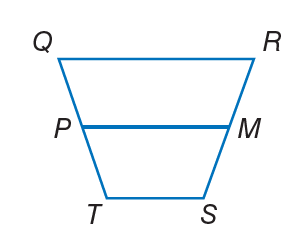Answer the mathemtical geometry problem and directly provide the correct option letter.
Question: For trapezoid Q R S T, M and P are midpoints of the legs. If T S = 2 x + 2, Q R = 5 x + 3, and P M = 13, find T S.
Choices: A: 4 B: 8 C: 12 D: 20 B 